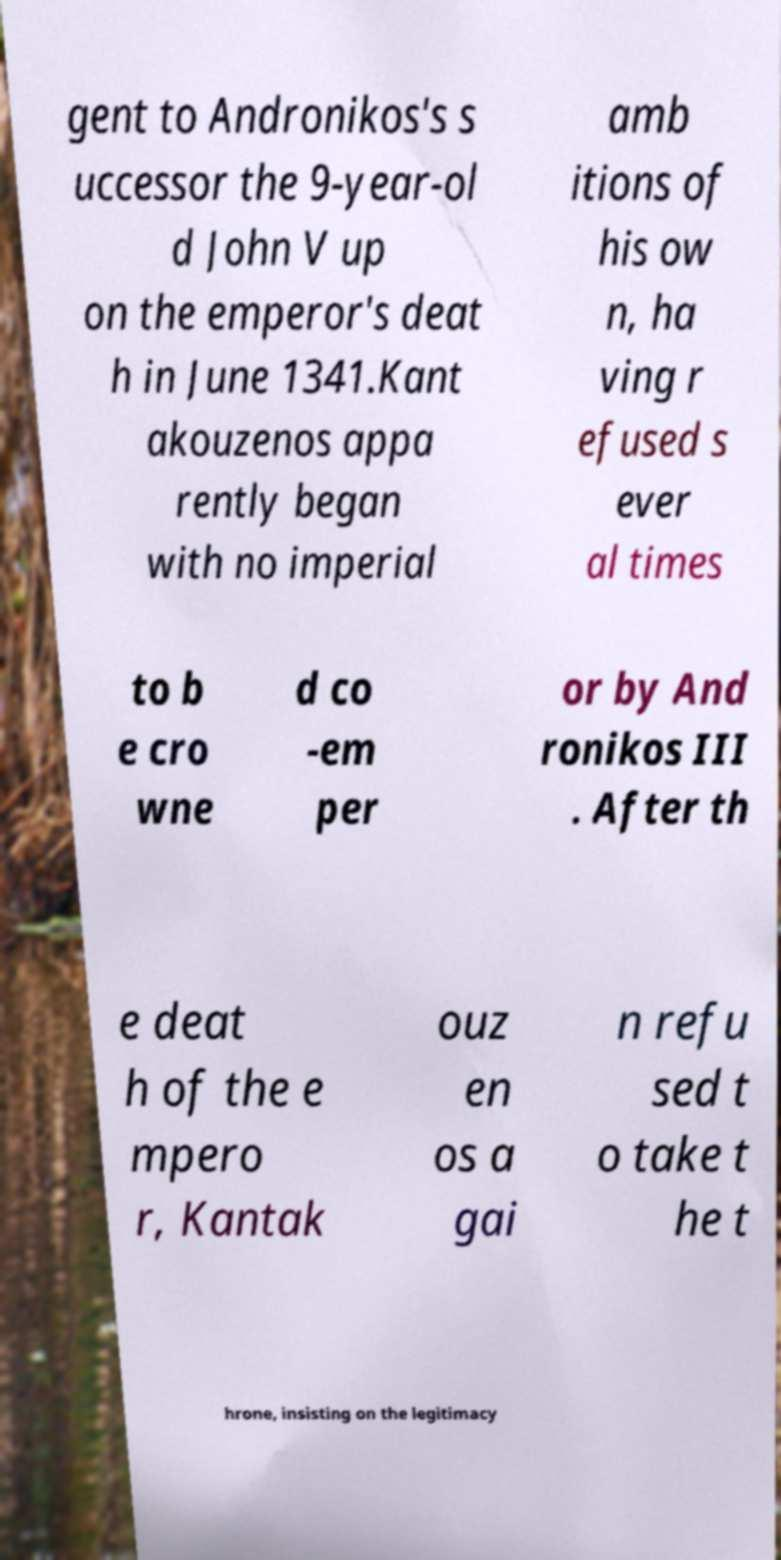Please read and relay the text visible in this image. What does it say? gent to Andronikos's s uccessor the 9-year-ol d John V up on the emperor's deat h in June 1341.Kant akouzenos appa rently began with no imperial amb itions of his ow n, ha ving r efused s ever al times to b e cro wne d co -em per or by And ronikos III . After th e deat h of the e mpero r, Kantak ouz en os a gai n refu sed t o take t he t hrone, insisting on the legitimacy 